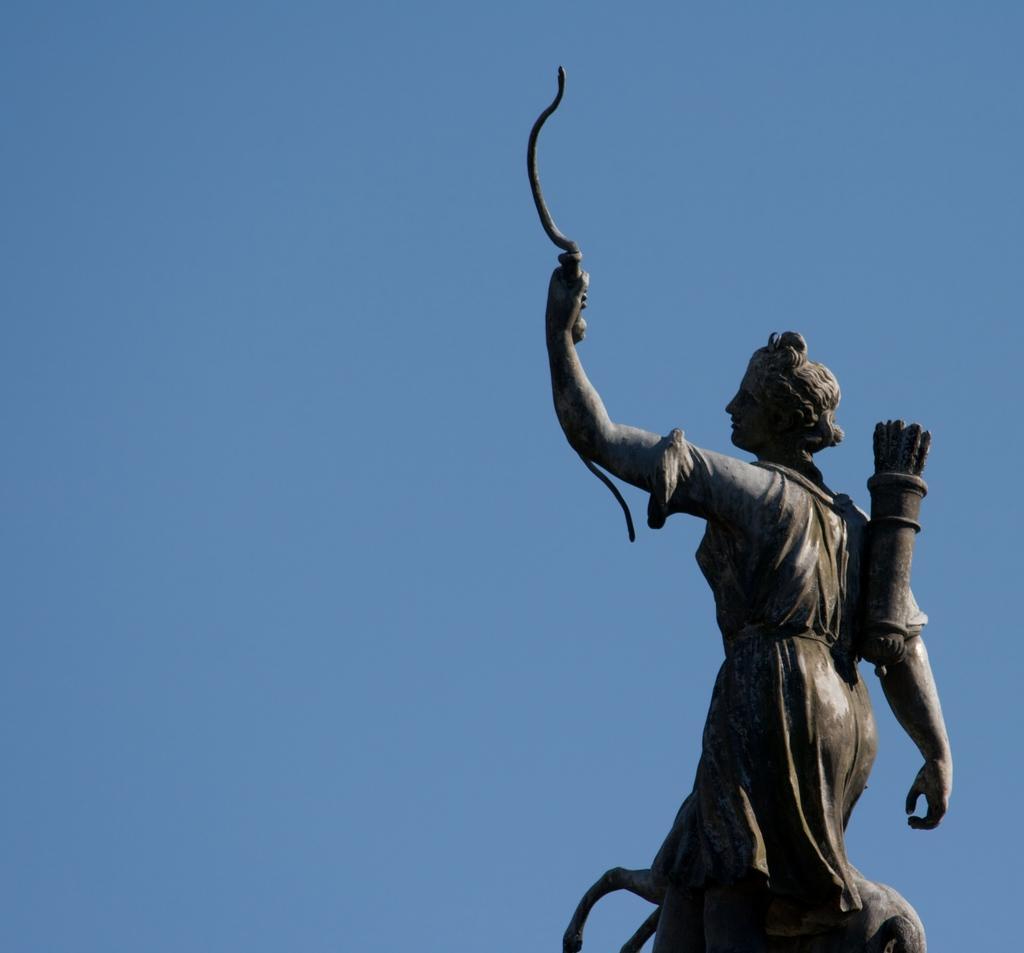Describe this image in one or two sentences. In this image we can see a sculpture of a person. Behind the sculpture, we can see the sky. 